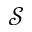<formula> <loc_0><loc_0><loc_500><loc_500>\mathcal { S }</formula> 